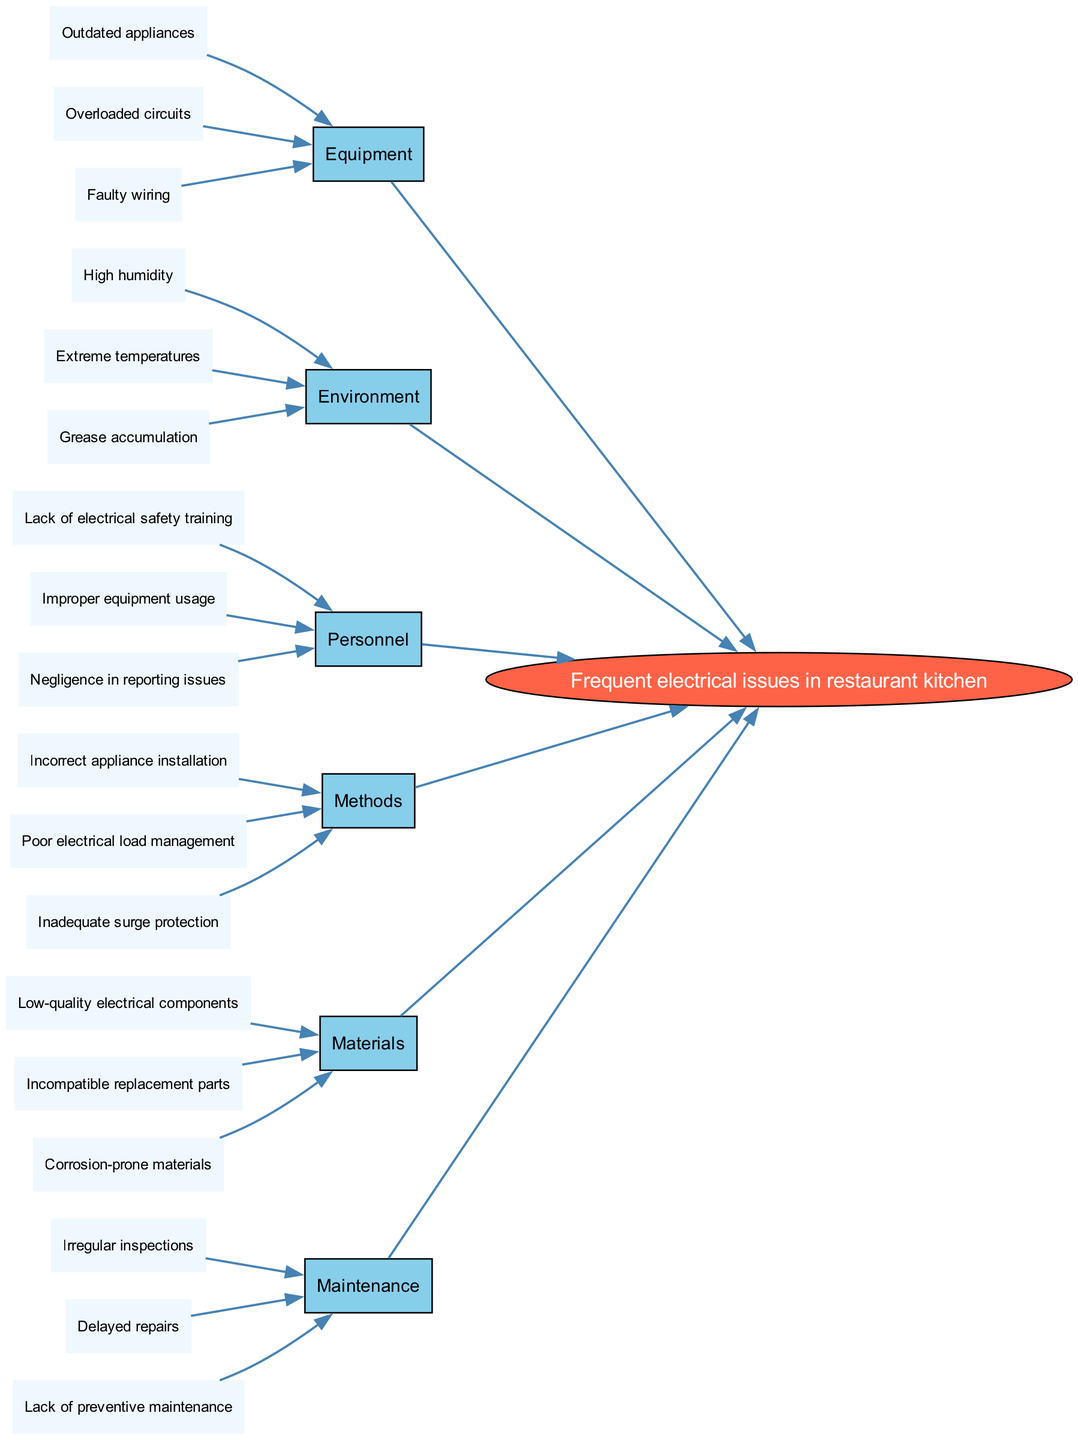What is the main problem addressed in the diagram? The main problem is clearly labeled in the center of the diagram; it states "Frequent electrical issues in restaurant kitchen."
Answer: Frequent electrical issues in restaurant kitchen How many categories are identified in the diagram? By counting the listed categories surrounding the main problem, we see six distinct categories including Equipment, Environment, Personnel, Methods, Materials, and Maintenance.
Answer: 6 Which category contains "Faulty wiring" as a cause? The cause "Faulty wiring" can be traced back to the category node labeled "Equipment," which is connected directly to the main problem.
Answer: Equipment Name one cause under the "Personnel" category. Looking at the causes listed under the "Personnel" category, one of them is "Lack of electrical safety training."
Answer: Lack of electrical safety training How many total causes are listed in the "Methods" category? The "Methods" category has three specific causes listed: "Incorrect appliance installation," "Poor electrical load management," and "Inadequate surge protection," totaling three causes.
Answer: 3 What category has the cause related to "Irregular inspections"? The cause "Irregular inspections" is under the category labeled "Maintenance," which like others, feeds into the main problem of electrical issues.
Answer: Maintenance Identify at least two environmental factors contributing to the main problem. The "Environment" category provides three causes, and at least two mentioned are "High humidity" and "Extreme temperatures."
Answer: High humidity, Extreme temperatures How does the cause "Delayer repairs" relate to the main problem? "Delayed repairs" falls under the "Maintenance" category, which contributes to the main problem by indicating that lack of prompt attention to issues can exacerbate electrical problems in the kitchen.
Answer: Delayed repairs Which category includes issues related to appliance installation? The cause related to appliance installation, "Incorrect appliance installation," is found in the "Methods" category, highlighting procedural issues impacting electrical reliability.
Answer: Methods 